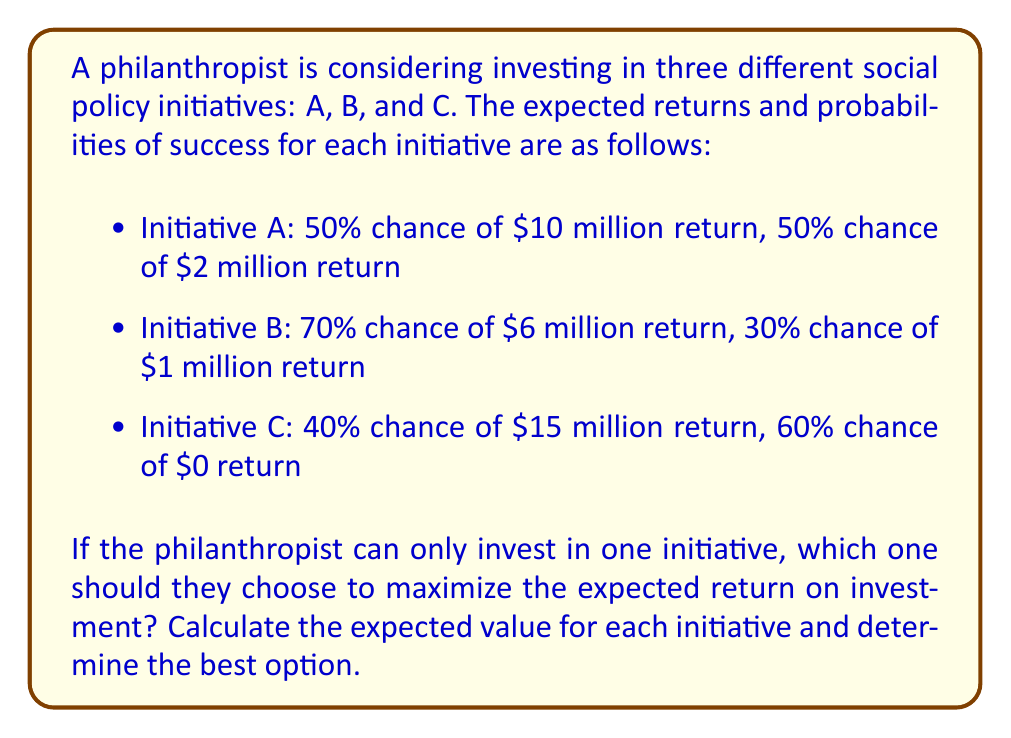Provide a solution to this math problem. To solve this problem, we need to calculate the expected value (EV) for each initiative and compare them:

1. For Initiative A:
   $$EV_A = (0.50 \times \$10\text{ million}) + (0.50 \times \$2\text{ million})$$
   $$EV_A = \$5\text{ million} + \$1\text{ million} = \$6\text{ million}$$

2. For Initiative B:
   $$EV_B = (0.70 \times \$6\text{ million}) + (0.30 \times \$1\text{ million})$$
   $$EV_B = \$4.2\text{ million} + \$0.3\text{ million} = \$4.5\text{ million}$$

3. For Initiative C:
   $$EV_C = (0.40 \times \$15\text{ million}) + (0.60 \times \$0)$$
   $$EV_C = \$6\text{ million} + \$0 = \$6\text{ million}$$

Comparing the expected values:
$$EV_A = \$6\text{ million}$$
$$EV_B = \$4.5\text{ million}$$
$$EV_C = \$6\text{ million}$$

We can see that Initiative A and Initiative C have the highest expected value of $6 million. Both are equally good choices in terms of maximizing the expected return on investment.
Answer: Initiative A or C, with an expected return of $6 million each. 